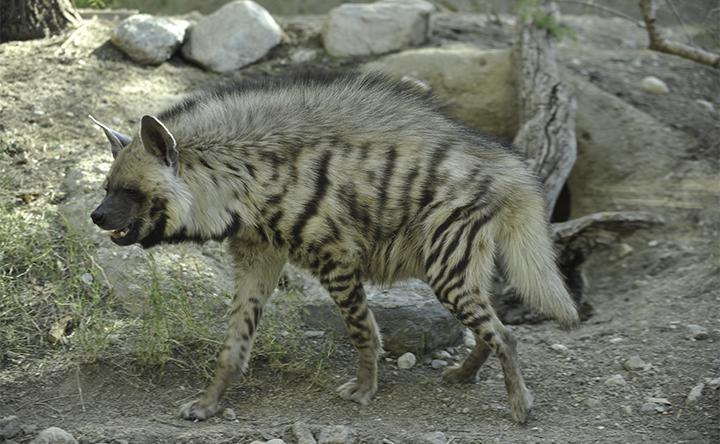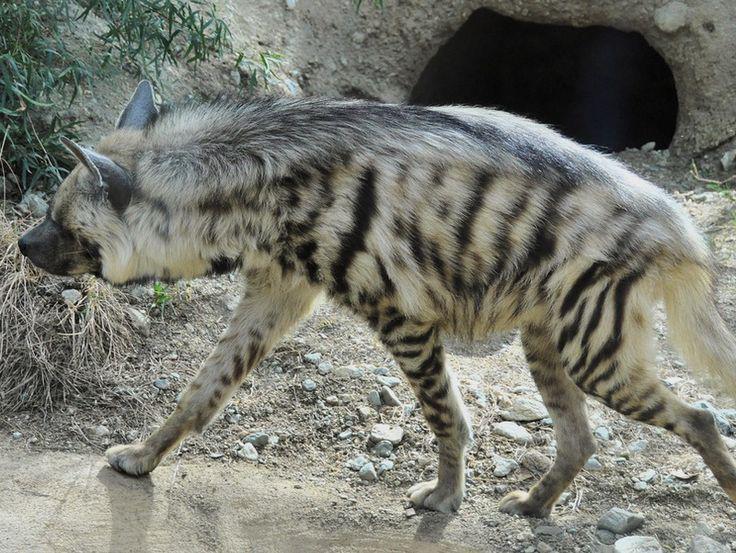The first image is the image on the left, the second image is the image on the right. Given the left and right images, does the statement "Each image contains exactly one canine-type animal, and the animals on the left and right have the same kind of fur markings." hold true? Answer yes or no. Yes. The first image is the image on the left, the second image is the image on the right. Evaluate the accuracy of this statement regarding the images: "The left and right image contains the same number of hyenas with at least one being striped.". Is it true? Answer yes or no. Yes. 